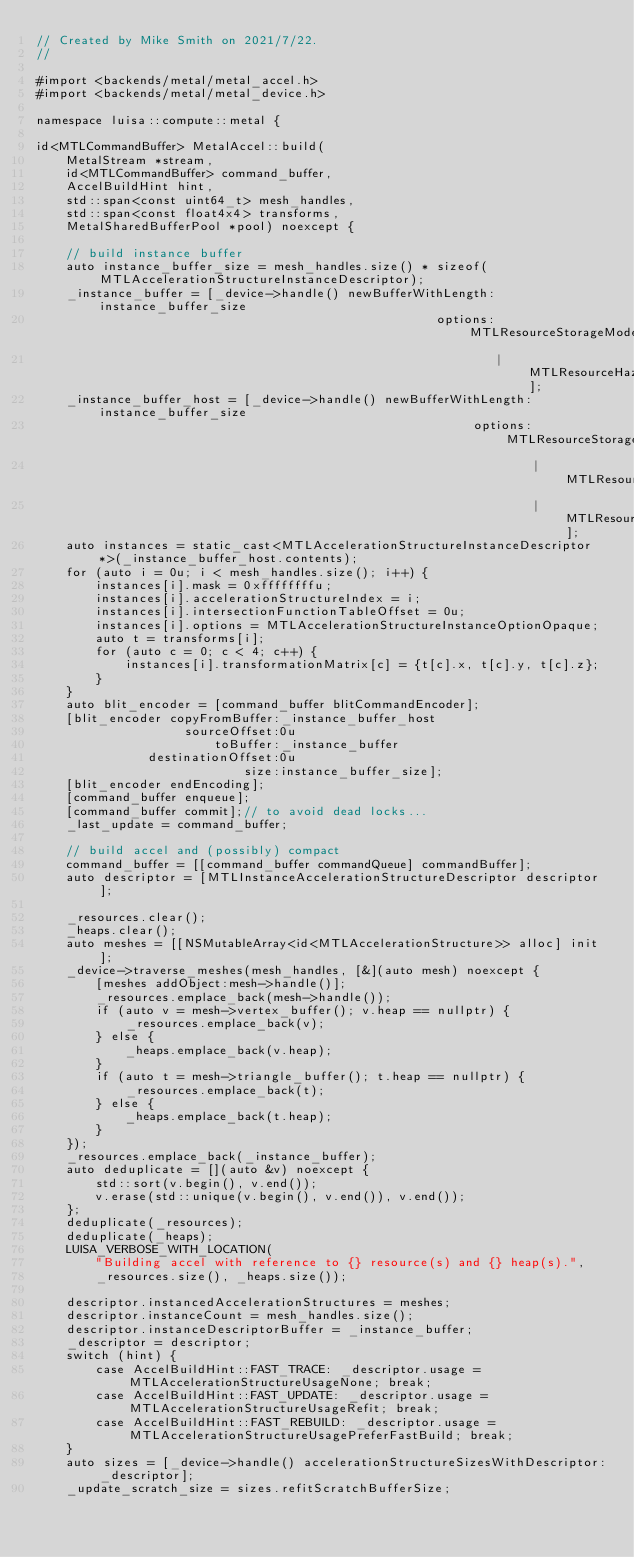<code> <loc_0><loc_0><loc_500><loc_500><_ObjectiveC_>// Created by Mike Smith on 2021/7/22.
//

#import <backends/metal/metal_accel.h>
#import <backends/metal/metal_device.h>

namespace luisa::compute::metal {

id<MTLCommandBuffer> MetalAccel::build(
    MetalStream *stream,
    id<MTLCommandBuffer> command_buffer,
    AccelBuildHint hint,
    std::span<const uint64_t> mesh_handles,
    std::span<const float4x4> transforms,
    MetalSharedBufferPool *pool) noexcept {

    // build instance buffer
    auto instance_buffer_size = mesh_handles.size() * sizeof(MTLAccelerationStructureInstanceDescriptor);
    _instance_buffer = [_device->handle() newBufferWithLength:instance_buffer_size
                                                      options:MTLResourceStorageModePrivate
                                                              | MTLResourceHazardTrackingModeUntracked];
    _instance_buffer_host = [_device->handle() newBufferWithLength:instance_buffer_size
                                                           options:MTLResourceStorageModeShared
                                                                   | MTLResourceHazardTrackingModeUntracked
                                                                   | MTLResourceOptionCPUCacheModeWriteCombined];
    auto instances = static_cast<MTLAccelerationStructureInstanceDescriptor *>(_instance_buffer_host.contents);
    for (auto i = 0u; i < mesh_handles.size(); i++) {
        instances[i].mask = 0xffffffffu;
        instances[i].accelerationStructureIndex = i;
        instances[i].intersectionFunctionTableOffset = 0u;
        instances[i].options = MTLAccelerationStructureInstanceOptionOpaque;
        auto t = transforms[i];
        for (auto c = 0; c < 4; c++) {
            instances[i].transformationMatrix[c] = {t[c].x, t[c].y, t[c].z};
        }
    }
    auto blit_encoder = [command_buffer blitCommandEncoder];
    [blit_encoder copyFromBuffer:_instance_buffer_host
                    sourceOffset:0u
                        toBuffer:_instance_buffer
               destinationOffset:0u
                            size:instance_buffer_size];
    [blit_encoder endEncoding];
    [command_buffer enqueue];
    [command_buffer commit];// to avoid dead locks...
    _last_update = command_buffer;

    // build accel and (possibly) compact
    command_buffer = [[command_buffer commandQueue] commandBuffer];
    auto descriptor = [MTLInstanceAccelerationStructureDescriptor descriptor];

    _resources.clear();
    _heaps.clear();
    auto meshes = [[NSMutableArray<id<MTLAccelerationStructure>> alloc] init];
    _device->traverse_meshes(mesh_handles, [&](auto mesh) noexcept {
        [meshes addObject:mesh->handle()];
        _resources.emplace_back(mesh->handle());
        if (auto v = mesh->vertex_buffer(); v.heap == nullptr) {
            _resources.emplace_back(v);
        } else {
            _heaps.emplace_back(v.heap);
        }
        if (auto t = mesh->triangle_buffer(); t.heap == nullptr) {
            _resources.emplace_back(t);
        } else {
            _heaps.emplace_back(t.heap);
        }
    });
    _resources.emplace_back(_instance_buffer);
    auto deduplicate = [](auto &v) noexcept {
        std::sort(v.begin(), v.end());
        v.erase(std::unique(v.begin(), v.end()), v.end());
    };
    deduplicate(_resources);
    deduplicate(_heaps);
    LUISA_VERBOSE_WITH_LOCATION(
        "Building accel with reference to {} resource(s) and {} heap(s).",
        _resources.size(), _heaps.size());

    descriptor.instancedAccelerationStructures = meshes;
    descriptor.instanceCount = mesh_handles.size();
    descriptor.instanceDescriptorBuffer = _instance_buffer;
    _descriptor = descriptor;
    switch (hint) {
        case AccelBuildHint::FAST_TRACE: _descriptor.usage = MTLAccelerationStructureUsageNone; break;
        case AccelBuildHint::FAST_UPDATE: _descriptor.usage = MTLAccelerationStructureUsageRefit; break;
        case AccelBuildHint::FAST_REBUILD: _descriptor.usage = MTLAccelerationStructureUsagePreferFastBuild; break;
    }
    auto sizes = [_device->handle() accelerationStructureSizesWithDescriptor:_descriptor];
    _update_scratch_size = sizes.refitScratchBufferSize;</code> 